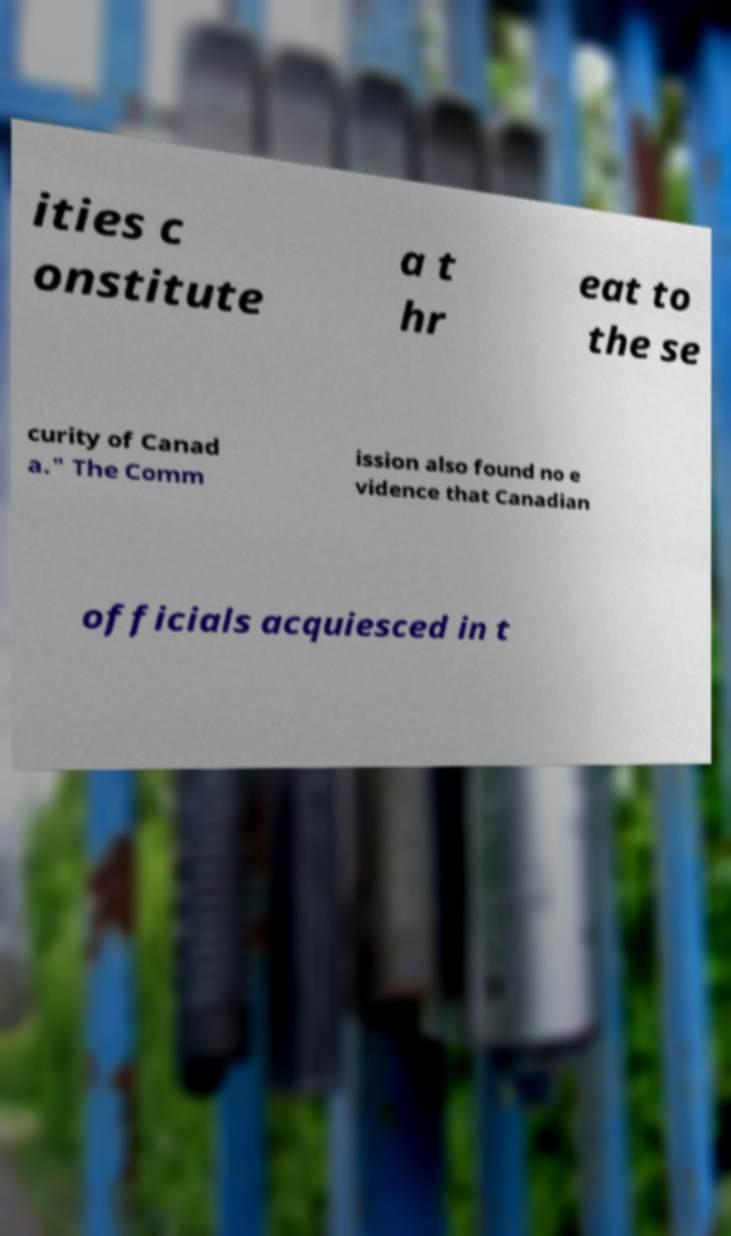Can you accurately transcribe the text from the provided image for me? ities c onstitute a t hr eat to the se curity of Canad a." The Comm ission also found no e vidence that Canadian officials acquiesced in t 